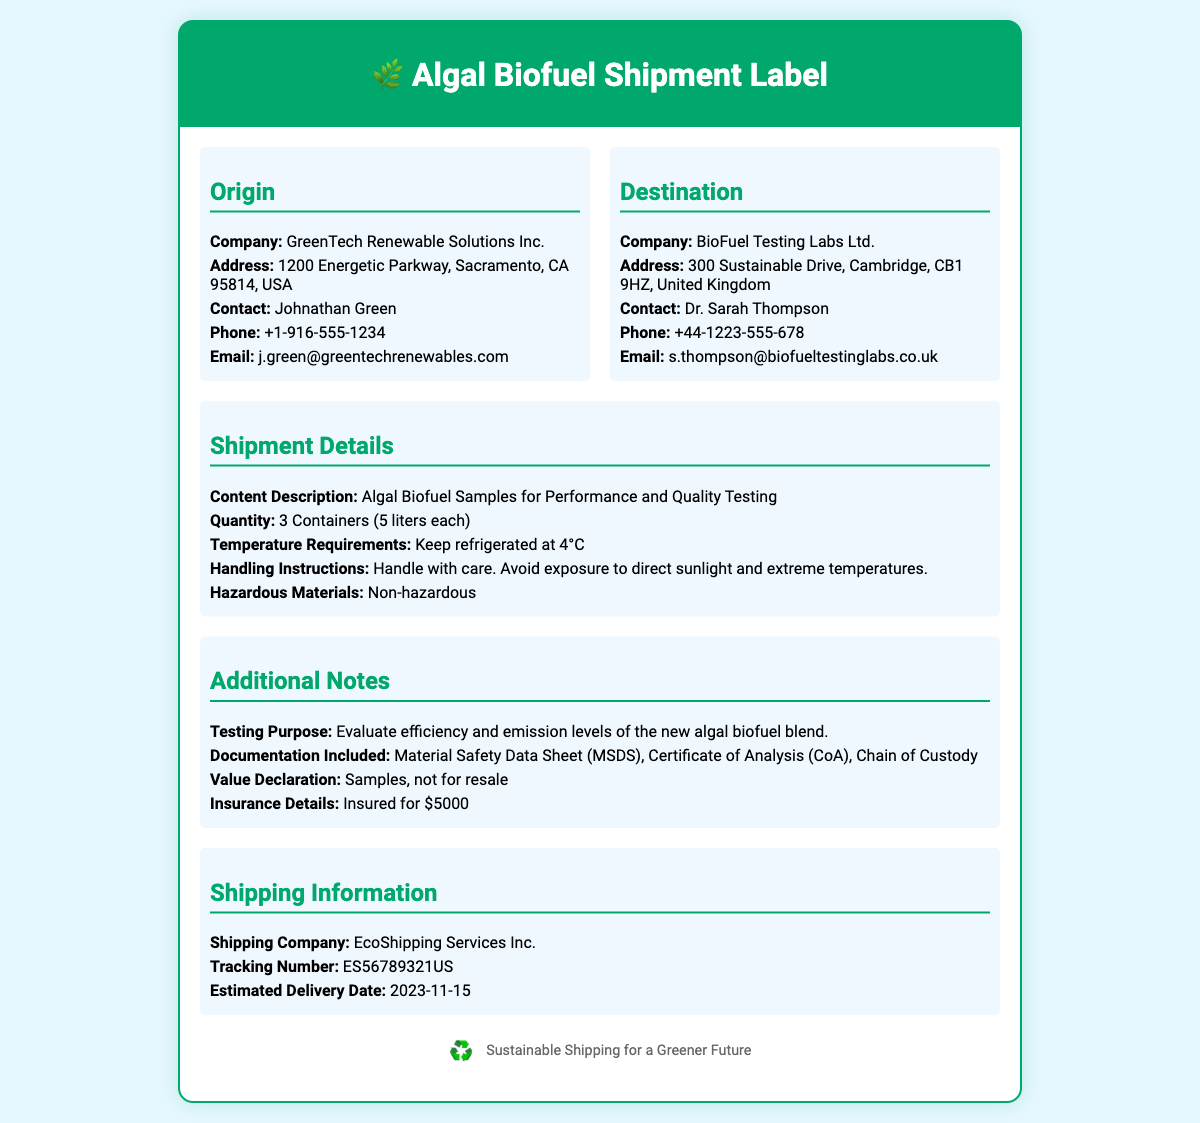What is the origin company name? The company from which the algal biofuel samples are shipped is clearly mentioned in the origin section as GreenTech Renewable Solutions Inc.
Answer: GreenTech Renewable Solutions Inc What is the destination company name? The company specified in the destination section where the samples are being shipped is BioFuel Testing Labs Ltd.
Answer: BioFuel Testing Labs Ltd How many containers are being shipped? The shipment details specify that there are 3 containers included in the shipment.
Answer: 3 Containers What is the total volume of the samples? Each container holds 5 liters, and with 3 containers, the total volume is 3 * 5 = 15 liters.
Answer: 15 liters What is the temperature requirement for the samples? The handling instructions in the shipment details clearly state that the samples must be kept refrigerated at 4°C.
Answer: 4°C Who is the contact person at the origin? The contact person mentioned in the origin section is Johnathan Green.
Answer: Johnathan Green What are the hazardous materials status of the samples? The shipment details indicate that the algal biofuel samples are non-hazardous.
Answer: Non-hazardous What is included with the shipment documentation? The additional notes list the documentation included as Material Safety Data Sheet (MSDS), Certificate of Analysis (CoA), Chain of Custody.
Answer: MSDS, CoA, Chain of Custody What is the shipping company name? The shipping information section identifies the shipping company as EcoShipping Services Inc.
Answer: EcoShipping Services Inc 